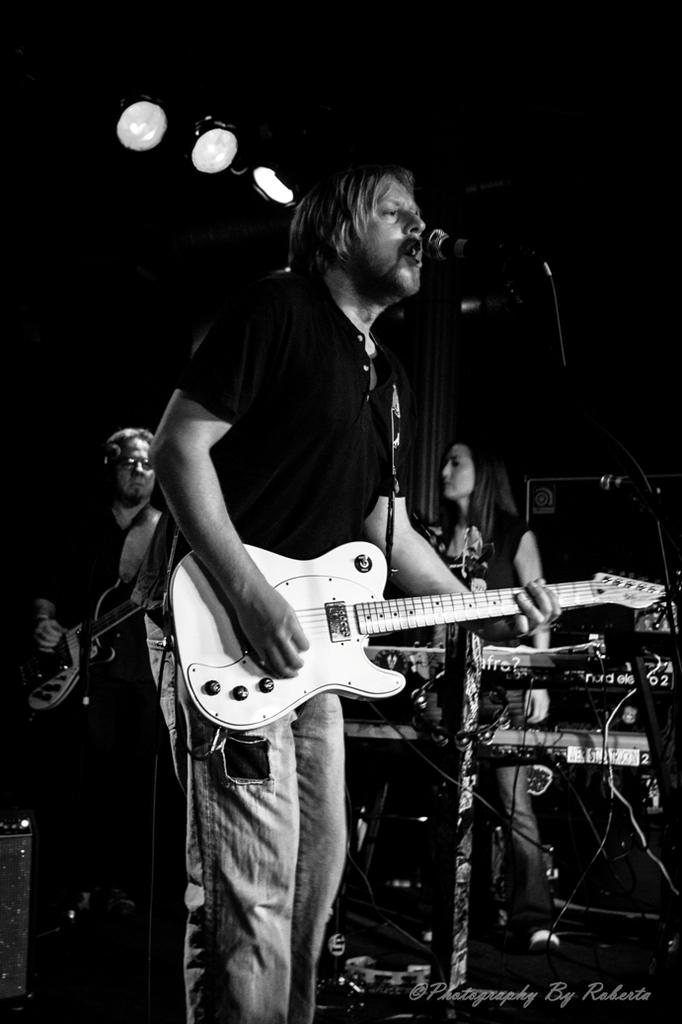What is the person in the image doing? The person is playing a guitar and singing. What is the person wearing? The person is wearing a black shirt. What object is the person standing in front of? The person is standing in front of a microphone. Are there any other people in the image? Yes, there are other people standing beside the person. How many deer can be seen in the image? There are no deer present in the image. What type of quiver is the person using to hold their guitar strings? The person is not using a quiver in the image; they are playing a guitar without any additional accessories. 